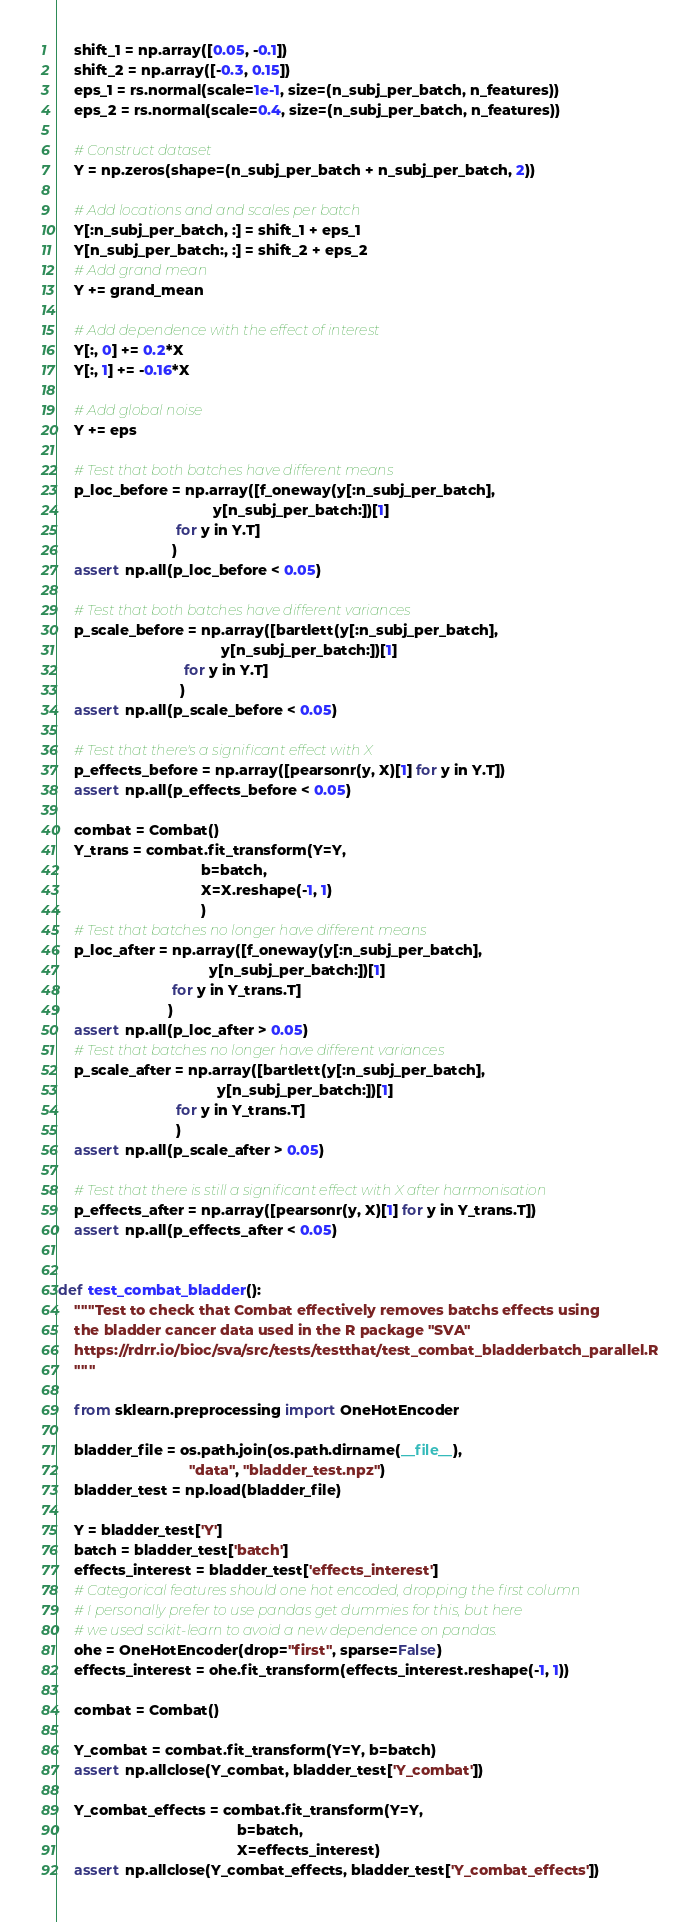<code> <loc_0><loc_0><loc_500><loc_500><_Python_>    shift_1 = np.array([0.05, -0.1])
    shift_2 = np.array([-0.3, 0.15])
    eps_1 = rs.normal(scale=1e-1, size=(n_subj_per_batch, n_features))
    eps_2 = rs.normal(scale=0.4, size=(n_subj_per_batch, n_features))

    # Construct dataset
    Y = np.zeros(shape=(n_subj_per_batch + n_subj_per_batch, 2))

    # Add locations and and scales per batch
    Y[:n_subj_per_batch, :] = shift_1 + eps_1
    Y[n_subj_per_batch:, :] = shift_2 + eps_2
    # Add grand mean
    Y += grand_mean

    # Add dependence with the effect of interest
    Y[:, 0] += 0.2*X
    Y[:, 1] += -0.16*X

    # Add global noise
    Y += eps

    # Test that both batches have different means
    p_loc_before = np.array([f_oneway(y[:n_subj_per_batch],
                                      y[n_subj_per_batch:])[1]
                             for y in Y.T]
                            )
    assert np.all(p_loc_before < 0.05)

    # Test that both batches have different variances
    p_scale_before = np.array([bartlett(y[:n_subj_per_batch],
                                        y[n_subj_per_batch:])[1]
                               for y in Y.T]
                              )
    assert np.all(p_scale_before < 0.05)

    # Test that there's a significant effect with X
    p_effects_before = np.array([pearsonr(y, X)[1] for y in Y.T])
    assert np.all(p_effects_before < 0.05)

    combat = Combat()
    Y_trans = combat.fit_transform(Y=Y,
                                   b=batch,
                                   X=X.reshape(-1, 1)
                                   )
    # Test that batches no longer have different means
    p_loc_after = np.array([f_oneway(y[:n_subj_per_batch],
                                     y[n_subj_per_batch:])[1]
                            for y in Y_trans.T]
                           )
    assert np.all(p_loc_after > 0.05)
    # Test that batches no longer have different variances
    p_scale_after = np.array([bartlett(y[:n_subj_per_batch],
                                       y[n_subj_per_batch:])[1]
                             for y in Y_trans.T]
                             )
    assert np.all(p_scale_after > 0.05)

    # Test that there is still a significant effect with X after harmonisation
    p_effects_after = np.array([pearsonr(y, X)[1] for y in Y_trans.T])
    assert np.all(p_effects_after < 0.05)


def test_combat_bladder():
    """Test to check that Combat effectively removes batchs effects using
    the bladder cancer data used in the R package "SVA"
    https://rdrr.io/bioc/sva/src/tests/testthat/test_combat_bladderbatch_parallel.R
    """

    from sklearn.preprocessing import OneHotEncoder

    bladder_file = os.path.join(os.path.dirname(__file__),
                                "data", "bladder_test.npz")
    bladder_test = np.load(bladder_file)

    Y = bladder_test['Y']
    batch = bladder_test['batch']
    effects_interest = bladder_test['effects_interest']
    # Categorical features should one hot encoded, dropping the first column
    # I personally prefer to use pandas get dummies for this, but here
    # we used scikit-learn to avoid a new dependence on pandas.
    ohe = OneHotEncoder(drop="first", sparse=False)
    effects_interest = ohe.fit_transform(effects_interest.reshape(-1, 1))

    combat = Combat()

    Y_combat = combat.fit_transform(Y=Y, b=batch)
    assert np.allclose(Y_combat, bladder_test['Y_combat'])

    Y_combat_effects = combat.fit_transform(Y=Y,
                                            b=batch,
                                            X=effects_interest)
    assert np.allclose(Y_combat_effects, bladder_test['Y_combat_effects'])
</code> 